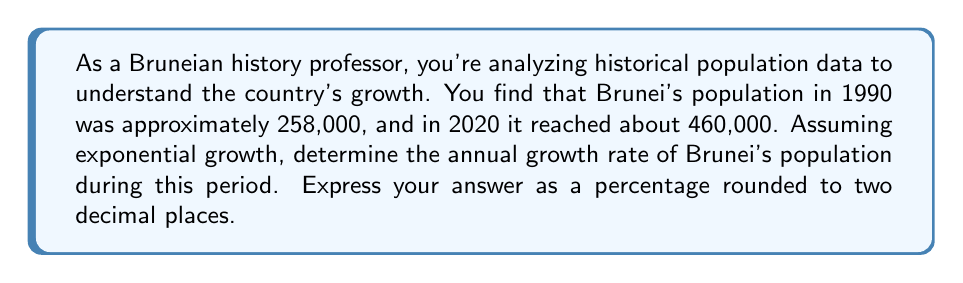Solve this math problem. To solve this problem, we'll use the exponential growth formula:

$$A = P(1 + r)^t$$

Where:
$A$ = Final amount (population in 2020)
$P$ = Initial amount (population in 1990)
$r$ = Annual growth rate (what we're solving for)
$t$ = Time period in years

Let's plug in the known values:

$$460000 = 258000(1 + r)^{30}$$

Now, let's solve for $r$:

1) Divide both sides by 258000:
   $$\frac{460000}{258000} = (1 + r)^{30}$$

2) Take the 30th root of both sides:
   $$\sqrt[30]{\frac{460000}{258000}} = 1 + r$$

3) Subtract 1 from both sides:
   $$\sqrt[30]{\frac{460000}{258000}} - 1 = r$$

4) Calculate the value:
   $$r \approx 0.019315$$

5) Convert to a percentage by multiplying by 100:
   $$r \approx 1.9315\%$$

6) Round to two decimal places:
   $$r \approx 1.93\%$$
Answer: The annual growth rate of Brunei's population between 1990 and 2020 was approximately 1.93%. 